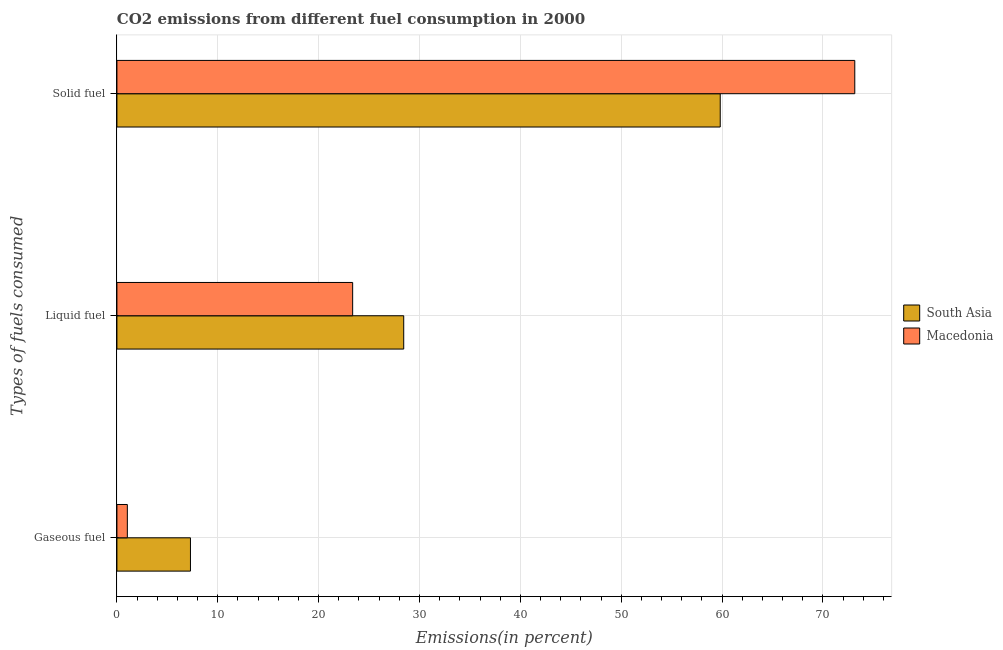How many groups of bars are there?
Offer a very short reply. 3. How many bars are there on the 3rd tick from the top?
Your answer should be compact. 2. What is the label of the 2nd group of bars from the top?
Offer a terse response. Liquid fuel. What is the percentage of solid fuel emission in Macedonia?
Offer a terse response. 73.16. Across all countries, what is the maximum percentage of gaseous fuel emission?
Keep it short and to the point. 7.29. Across all countries, what is the minimum percentage of liquid fuel emission?
Your answer should be very brief. 23.37. In which country was the percentage of liquid fuel emission maximum?
Your response must be concise. South Asia. In which country was the percentage of gaseous fuel emission minimum?
Provide a short and direct response. Macedonia. What is the total percentage of gaseous fuel emission in the graph?
Ensure brevity in your answer.  8.32. What is the difference between the percentage of solid fuel emission in South Asia and that in Macedonia?
Make the answer very short. -13.34. What is the difference between the percentage of liquid fuel emission in South Asia and the percentage of gaseous fuel emission in Macedonia?
Provide a succinct answer. 27.4. What is the average percentage of gaseous fuel emission per country?
Ensure brevity in your answer.  4.16. What is the difference between the percentage of solid fuel emission and percentage of liquid fuel emission in Macedonia?
Make the answer very short. 49.79. What is the ratio of the percentage of solid fuel emission in South Asia to that in Macedonia?
Your answer should be compact. 0.82. What is the difference between the highest and the second highest percentage of liquid fuel emission?
Keep it short and to the point. 5.06. What is the difference between the highest and the lowest percentage of liquid fuel emission?
Provide a short and direct response. 5.06. In how many countries, is the percentage of solid fuel emission greater than the average percentage of solid fuel emission taken over all countries?
Provide a succinct answer. 1. Is the sum of the percentage of liquid fuel emission in South Asia and Macedonia greater than the maximum percentage of solid fuel emission across all countries?
Your answer should be compact. No. What does the 1st bar from the top in Solid fuel represents?
Provide a short and direct response. Macedonia. What does the 2nd bar from the bottom in Liquid fuel represents?
Provide a succinct answer. Macedonia. Is it the case that in every country, the sum of the percentage of gaseous fuel emission and percentage of liquid fuel emission is greater than the percentage of solid fuel emission?
Your answer should be compact. No. How many bars are there?
Offer a very short reply. 6. How many countries are there in the graph?
Offer a terse response. 2. Does the graph contain any zero values?
Provide a succinct answer. No. Does the graph contain grids?
Make the answer very short. Yes. How many legend labels are there?
Give a very brief answer. 2. How are the legend labels stacked?
Ensure brevity in your answer.  Vertical. What is the title of the graph?
Make the answer very short. CO2 emissions from different fuel consumption in 2000. Does "Qatar" appear as one of the legend labels in the graph?
Your response must be concise. No. What is the label or title of the X-axis?
Your answer should be compact. Emissions(in percent). What is the label or title of the Y-axis?
Keep it short and to the point. Types of fuels consumed. What is the Emissions(in percent) in South Asia in Gaseous fuel?
Keep it short and to the point. 7.29. What is the Emissions(in percent) in Macedonia in Gaseous fuel?
Your answer should be very brief. 1.03. What is the Emissions(in percent) in South Asia in Liquid fuel?
Offer a very short reply. 28.44. What is the Emissions(in percent) of Macedonia in Liquid fuel?
Provide a succinct answer. 23.37. What is the Emissions(in percent) of South Asia in Solid fuel?
Offer a terse response. 59.82. What is the Emissions(in percent) of Macedonia in Solid fuel?
Your answer should be very brief. 73.16. Across all Types of fuels consumed, what is the maximum Emissions(in percent) in South Asia?
Offer a very short reply. 59.82. Across all Types of fuels consumed, what is the maximum Emissions(in percent) of Macedonia?
Offer a terse response. 73.16. Across all Types of fuels consumed, what is the minimum Emissions(in percent) of South Asia?
Offer a very short reply. 7.29. Across all Types of fuels consumed, what is the minimum Emissions(in percent) of Macedonia?
Your answer should be compact. 1.03. What is the total Emissions(in percent) of South Asia in the graph?
Provide a succinct answer. 95.55. What is the total Emissions(in percent) in Macedonia in the graph?
Provide a succinct answer. 97.57. What is the difference between the Emissions(in percent) of South Asia in Gaseous fuel and that in Liquid fuel?
Provide a succinct answer. -21.15. What is the difference between the Emissions(in percent) in Macedonia in Gaseous fuel and that in Liquid fuel?
Give a very brief answer. -22.34. What is the difference between the Emissions(in percent) in South Asia in Gaseous fuel and that in Solid fuel?
Your response must be concise. -52.53. What is the difference between the Emissions(in percent) of Macedonia in Gaseous fuel and that in Solid fuel?
Make the answer very short. -72.13. What is the difference between the Emissions(in percent) in South Asia in Liquid fuel and that in Solid fuel?
Ensure brevity in your answer.  -31.38. What is the difference between the Emissions(in percent) in Macedonia in Liquid fuel and that in Solid fuel?
Your answer should be very brief. -49.79. What is the difference between the Emissions(in percent) of South Asia in Gaseous fuel and the Emissions(in percent) of Macedonia in Liquid fuel?
Offer a very short reply. -16.08. What is the difference between the Emissions(in percent) in South Asia in Gaseous fuel and the Emissions(in percent) in Macedonia in Solid fuel?
Offer a very short reply. -65.87. What is the difference between the Emissions(in percent) of South Asia in Liquid fuel and the Emissions(in percent) of Macedonia in Solid fuel?
Your answer should be compact. -44.72. What is the average Emissions(in percent) of South Asia per Types of fuels consumed?
Your response must be concise. 31.85. What is the average Emissions(in percent) of Macedonia per Types of fuels consumed?
Give a very brief answer. 32.52. What is the difference between the Emissions(in percent) of South Asia and Emissions(in percent) of Macedonia in Gaseous fuel?
Keep it short and to the point. 6.26. What is the difference between the Emissions(in percent) in South Asia and Emissions(in percent) in Macedonia in Liquid fuel?
Give a very brief answer. 5.06. What is the difference between the Emissions(in percent) of South Asia and Emissions(in percent) of Macedonia in Solid fuel?
Your response must be concise. -13.34. What is the ratio of the Emissions(in percent) of South Asia in Gaseous fuel to that in Liquid fuel?
Your answer should be very brief. 0.26. What is the ratio of the Emissions(in percent) in Macedonia in Gaseous fuel to that in Liquid fuel?
Ensure brevity in your answer.  0.04. What is the ratio of the Emissions(in percent) of South Asia in Gaseous fuel to that in Solid fuel?
Keep it short and to the point. 0.12. What is the ratio of the Emissions(in percent) in Macedonia in Gaseous fuel to that in Solid fuel?
Provide a short and direct response. 0.01. What is the ratio of the Emissions(in percent) in South Asia in Liquid fuel to that in Solid fuel?
Your answer should be compact. 0.48. What is the ratio of the Emissions(in percent) of Macedonia in Liquid fuel to that in Solid fuel?
Give a very brief answer. 0.32. What is the difference between the highest and the second highest Emissions(in percent) of South Asia?
Make the answer very short. 31.38. What is the difference between the highest and the second highest Emissions(in percent) of Macedonia?
Give a very brief answer. 49.79. What is the difference between the highest and the lowest Emissions(in percent) of South Asia?
Your response must be concise. 52.53. What is the difference between the highest and the lowest Emissions(in percent) in Macedonia?
Ensure brevity in your answer.  72.13. 